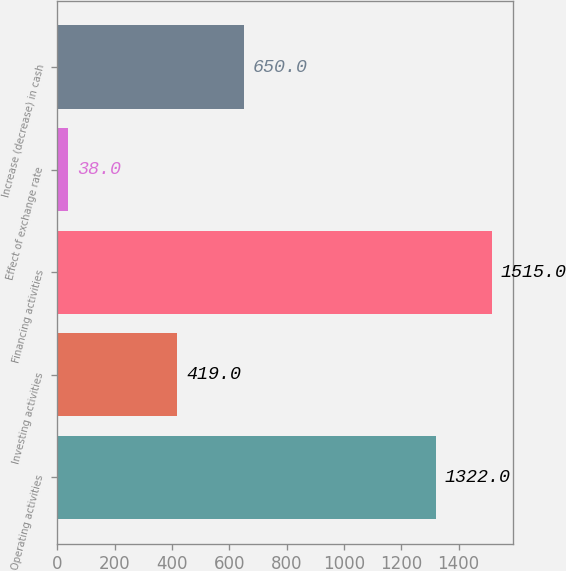Convert chart. <chart><loc_0><loc_0><loc_500><loc_500><bar_chart><fcel>Operating activities<fcel>Investing activities<fcel>Financing activities<fcel>Effect of exchange rate<fcel>Increase (decrease) in cash<nl><fcel>1322<fcel>419<fcel>1515<fcel>38<fcel>650<nl></chart> 